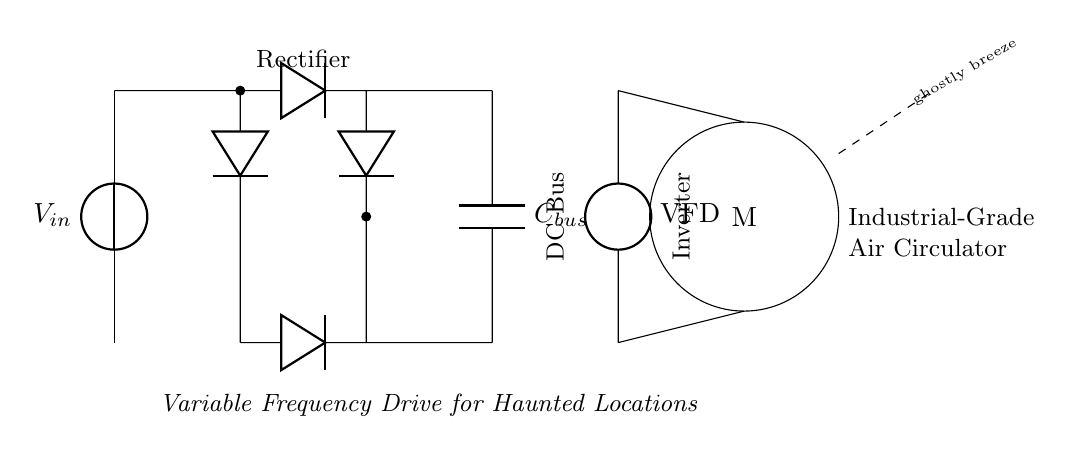What type of power supply is used in this circuit? The circuit uses a voltage source, indicated by the symbol for a power supply, labeled as Vin. This shows that the circuit is connected to an external supply to power its components.
Answer: voltage source What is the purpose of the capacitors in this circuit? The capacitor Cbus functions to smooth out the voltage fluctuations in the DC Bus and store energy to provide stability to the circuit, minimizing ripple current.
Answer: smooth voltage fluctuations How does the inverter contribute to the operation of the circuit? The inverter converts the DC voltage from the bus into AC voltage with variable frequency, which allows for control over the speed of the motor connected to the air circulator.
Answer: converts DC to AC Which component controls the speed of the industrial-grade air circulator? The variable frequency drive (VFD) is responsible for adjusting the frequency of the AC signal supplied to the motor, thus controlling its speed effectively.
Answer: variable frequency drive What is the function of the diodes in the rectifier section? The diodes allow current to flow in only one direction, converting AC input from the voltage source into a pulsed DC output for the circuit. This prevents backflow and protects the circuit.
Answer: convert AC to DC How is the circuit designed to address supernatural locations? The circuit's configuration includes elements like a variable frequency drive and a fan motor specifically meant to create airflow without direct intervention, which aligns with the theme of managing air movement in haunted locations.
Answer: airflow management 